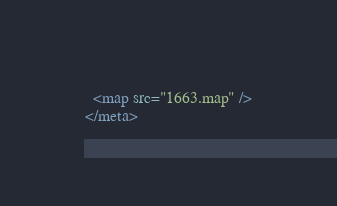Convert code to text. <code><loc_0><loc_0><loc_500><loc_500><_XML_>  <map src="1663.map" />
</meta></code> 